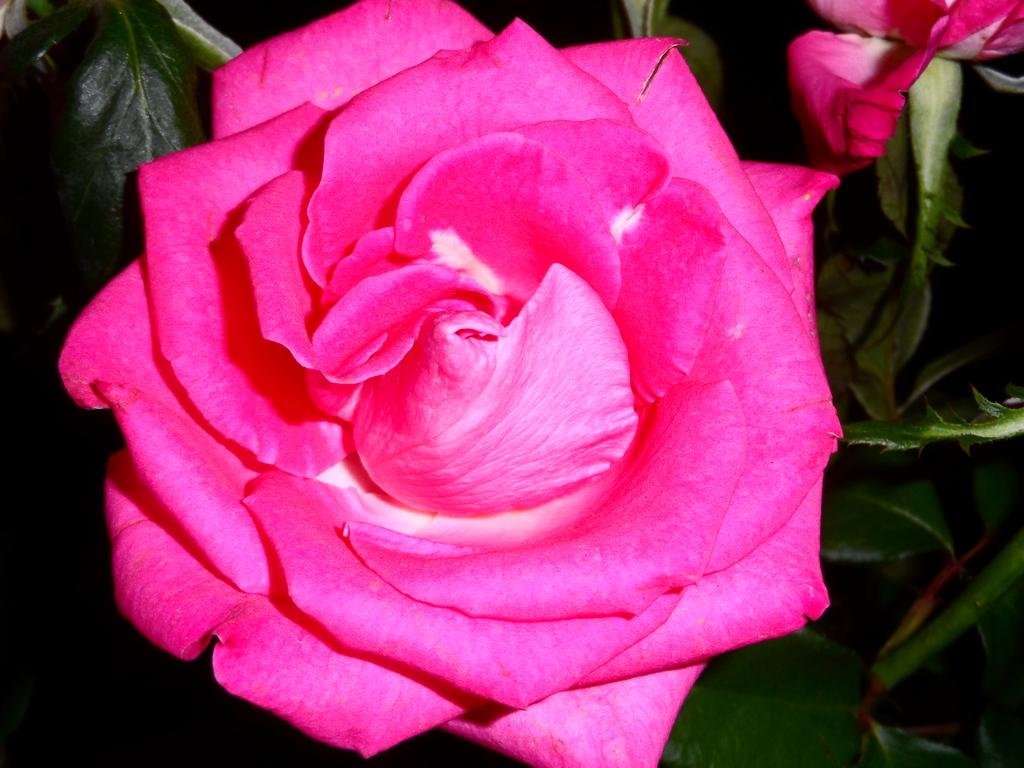What type of plants can be seen in the image? There are flowers and green leaves in the image. Can you describe the color of the flowers? The provided facts do not mention the color of the flowers, so we cannot definitively answer that question. What type of music can be heard playing in the background of the image? There is no music present in the image, as it is a still image of flowers and green leaves. Can you describe the engine that powers the art in the image? There is no art or engine present in the image; it is a simple depiction of flowers and green leaves. 